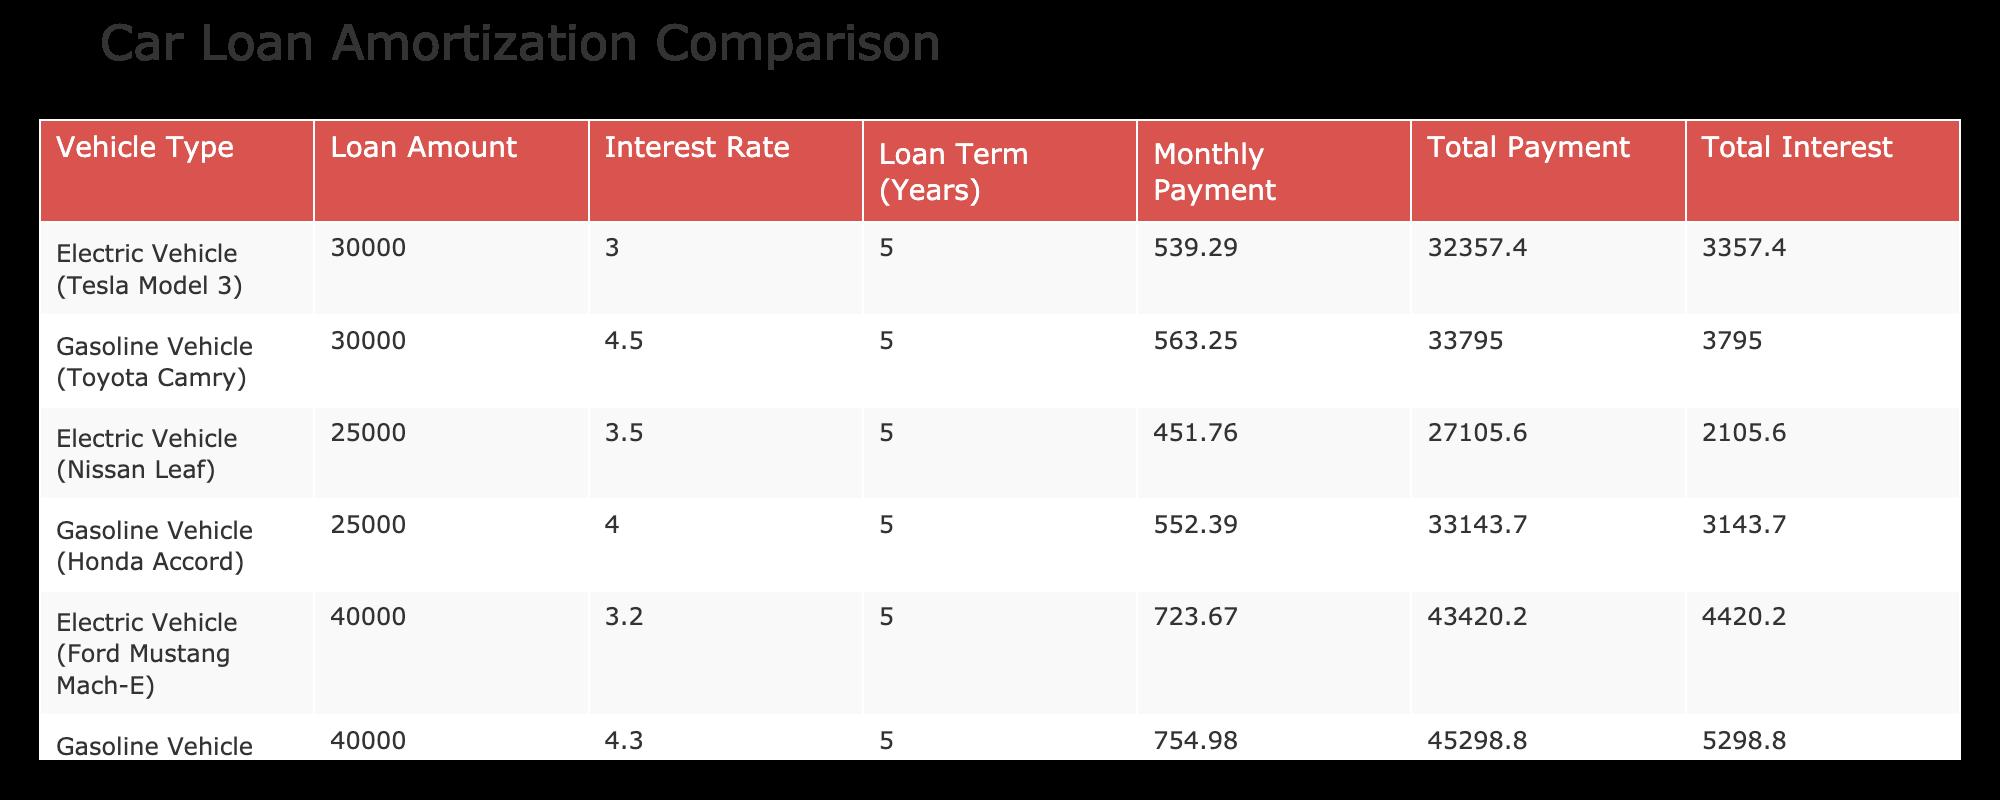What is the monthly payment for the electric vehicle Tesla Model 3? The table lists the monthly payment for the Tesla Model 3 as 539.29. Therefore, the value can directly be retrieved from the corresponding row for this vehicle type.
Answer: 539.29 What is the total interest paid for the gasoline vehicle Toyota Camry? The total interest paid for the Toyota Camry is explicitly given in the table as 3795.00. This can be directly referenced without requiring calculations.
Answer: 3795.00 How much more total payment is made for the gasoline vehicle Chevrolet Malibu compared to the electric vehicle Ford Mustang Mach-E? The total payment for the Chevrolet Malibu is 45298.80, and for the Ford Mustang Mach-E it's 43420.20. The difference is calculated as 45298.80 - 43420.20 = 878.60. Therefore, the Chevrolet Malibu requires 878.60 more total payment than the Ford Mustang.
Answer: 878.60 Which vehicle has the lowest monthly payment among the listed options? The monthly payments are: Tesla Model 3 (539.29), Nissan Leaf (451.76), Honda Accord (552.39), Ford Mustang Mach-E (723.67), and Chevrolet Malibu (754.98). The Nissan Leaf has the lowest monthly payment of 451.76 when compared to the others.
Answer: Nissan Leaf Is the total payment for the electric vehicle Nissan Leaf less than 30000? The total payment for the Nissan Leaf is 27105.60, which is less than 30000. This value can be compared directly to 30000 to verify its truthfulness.
Answer: Yes How much total interest does the cheapest gasoline vehicle (Toyota Camry) have when compared to the most expensive electric vehicle (Ford Mustang Mach-E)? The total interest for the Toyota Camry is 3795.00, while the total interest for the Ford Mustang Mach-E is 4420.20. The difference calculated is 4420.20 - 3795.00 = 625.20, meaning the Ford Mustang Mach-E has a higher total interest of 625.20 compared to the Toyota Camry.
Answer: 625.20 What is the average total payment for electric vehicles listed? The total payments for electric vehicles are: 32357.40 (Tesla Model 3), 27105.60 (Nissan Leaf), and 43420.20 (Ford Mustang Mach-E). To find the average, we sum these up: 32357.40 + 27105.60 + 43420.20 = 102883.20 and divide by the number of vehicles (3), which results in 102883.20 / 3 = 34361.07.
Answer: 34361.07 Which vehicle has the highest total interest among the options? The total interests listed are 3357.40 (Tesla Model 3), 3795.00 (Toyota Camry), 2105.60 (Nissan Leaf), 3143.70 (Honda Accord), 4420.20 (Ford Mustang Mach-E), and 5298.80 (Chevrolet Malibu). Comparing these values, the Chevrolet Malibu has the highest total interest.
Answer: Chevrolet Malibu Is the total payment of the Ford Mustang Mach-E more than the average total payment of all vehicles? The total payment for the Ford Mustang Mach-E is 43420.20. First, we calculate the total payments: 32357.40 + 33795.00 + 27105.60 + 33143.70 + 43420.20 + 45298.80 = 184120.70. The average total payment is then 184120.70 / 6 = 30686.78. Since 43420.20 is greater than 30686.78, this statement is true.
Answer: Yes 